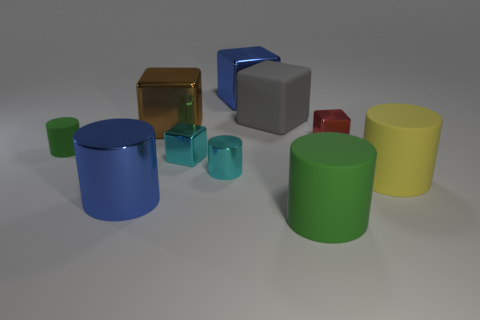Are there any objects that are the same shape but different sizes? Yes, there are cylindrical objects of varying sizes. The blue cylinders come in two different sizes and the green cylinders also feature a small and a large version. Could you use these objects to explain the concept of scaling? Certainly! Scaling refers to the proportional increase or decrease in size of an object. In the image, the smaller blue and green cylinders can be seen as scaled-down versions of their larger counterparts. Despite the change in size, their proportions remain consistent. This illustrates the concept of scaling quite well. 